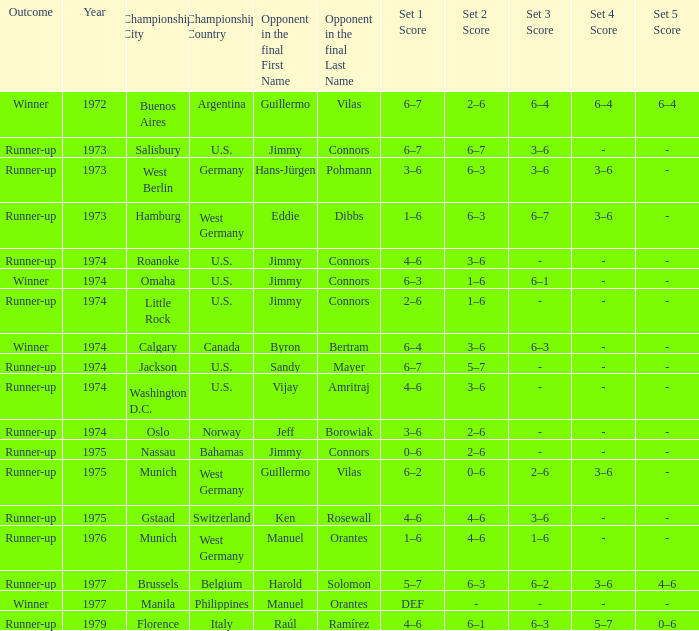What was the final score with Guillermo Vilas as the opponent in the final, that happened after 1972? 6–2, 0–6, 2–6, 3–6. 